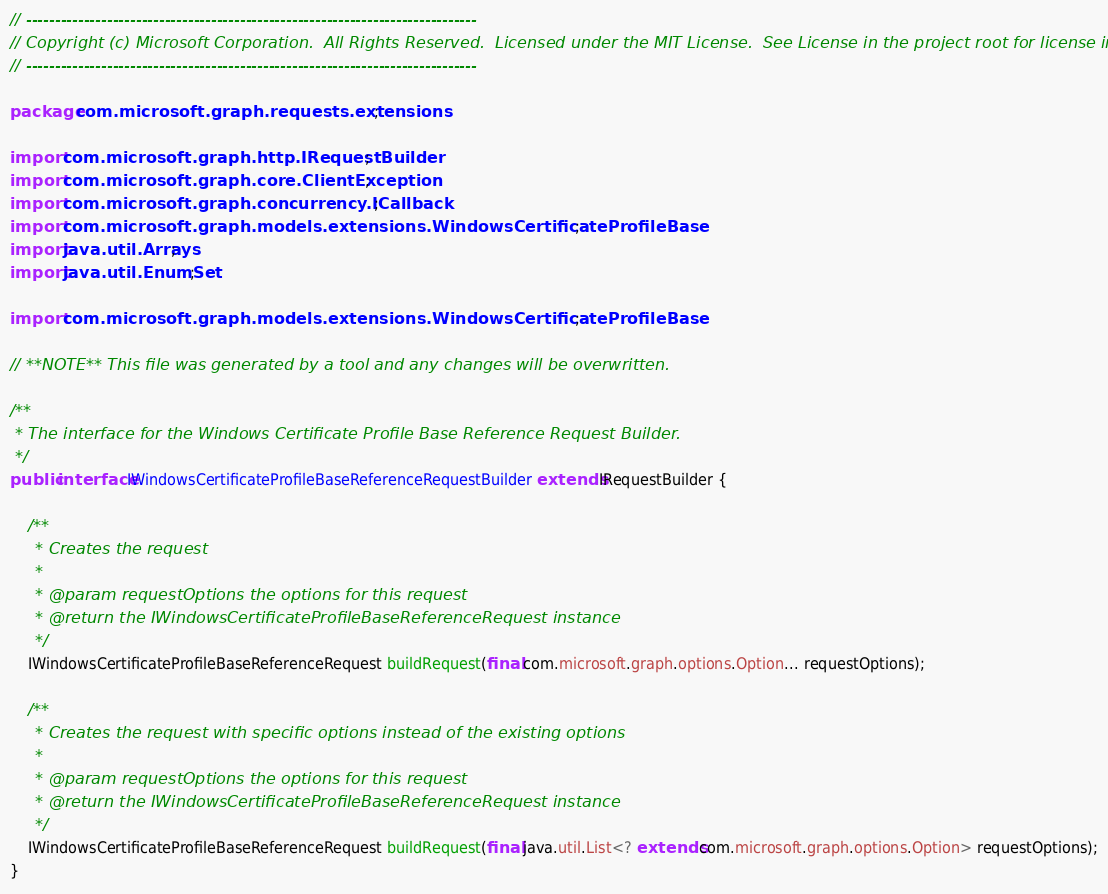Convert code to text. <code><loc_0><loc_0><loc_500><loc_500><_Java_>// ------------------------------------------------------------------------------
// Copyright (c) Microsoft Corporation.  All Rights Reserved.  Licensed under the MIT License.  See License in the project root for license information.
// ------------------------------------------------------------------------------

package com.microsoft.graph.requests.extensions;

import com.microsoft.graph.http.IRequestBuilder;
import com.microsoft.graph.core.ClientException;
import com.microsoft.graph.concurrency.ICallback;
import com.microsoft.graph.models.extensions.WindowsCertificateProfileBase;
import java.util.Arrays;
import java.util.EnumSet;

import com.microsoft.graph.models.extensions.WindowsCertificateProfileBase;

// **NOTE** This file was generated by a tool and any changes will be overwritten.

/**
 * The interface for the Windows Certificate Profile Base Reference Request Builder.
 */
public interface IWindowsCertificateProfileBaseReferenceRequestBuilder extends IRequestBuilder {

    /**
     * Creates the request
     *
     * @param requestOptions the options for this request
     * @return the IWindowsCertificateProfileBaseReferenceRequest instance
     */
    IWindowsCertificateProfileBaseReferenceRequest buildRequest(final com.microsoft.graph.options.Option... requestOptions);

    /**
     * Creates the request with specific options instead of the existing options
     *
     * @param requestOptions the options for this request
     * @return the IWindowsCertificateProfileBaseReferenceRequest instance
     */
    IWindowsCertificateProfileBaseReferenceRequest buildRequest(final java.util.List<? extends com.microsoft.graph.options.Option> requestOptions);
}
</code> 